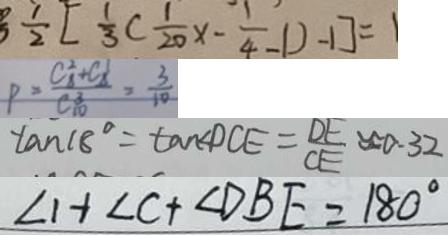Convert formula to latex. <formula><loc_0><loc_0><loc_500><loc_500>\frac { 1 } { 2 } [ \frac { 1 } { 3 } ( \frac { 1 } { 2 0 } x - \frac { 1 } { 4 } - 1 ) - 1 ] = 1 
 P = \frac { C _ { 8 } ^ { 2 } + C _ { 8 } ^ { 1 } } { C _ { 1 0 } ^ { 3 } } = \frac { 3 } { 1 0 } 
 \tan 1 8 ^ { \circ } = \tan \angle D C E = \frac { D E } { C E } \approx 0 . 3 2 
 \angle 1 + \angle C + \angle D B E = 1 8 0 ^ { \circ }</formula> 